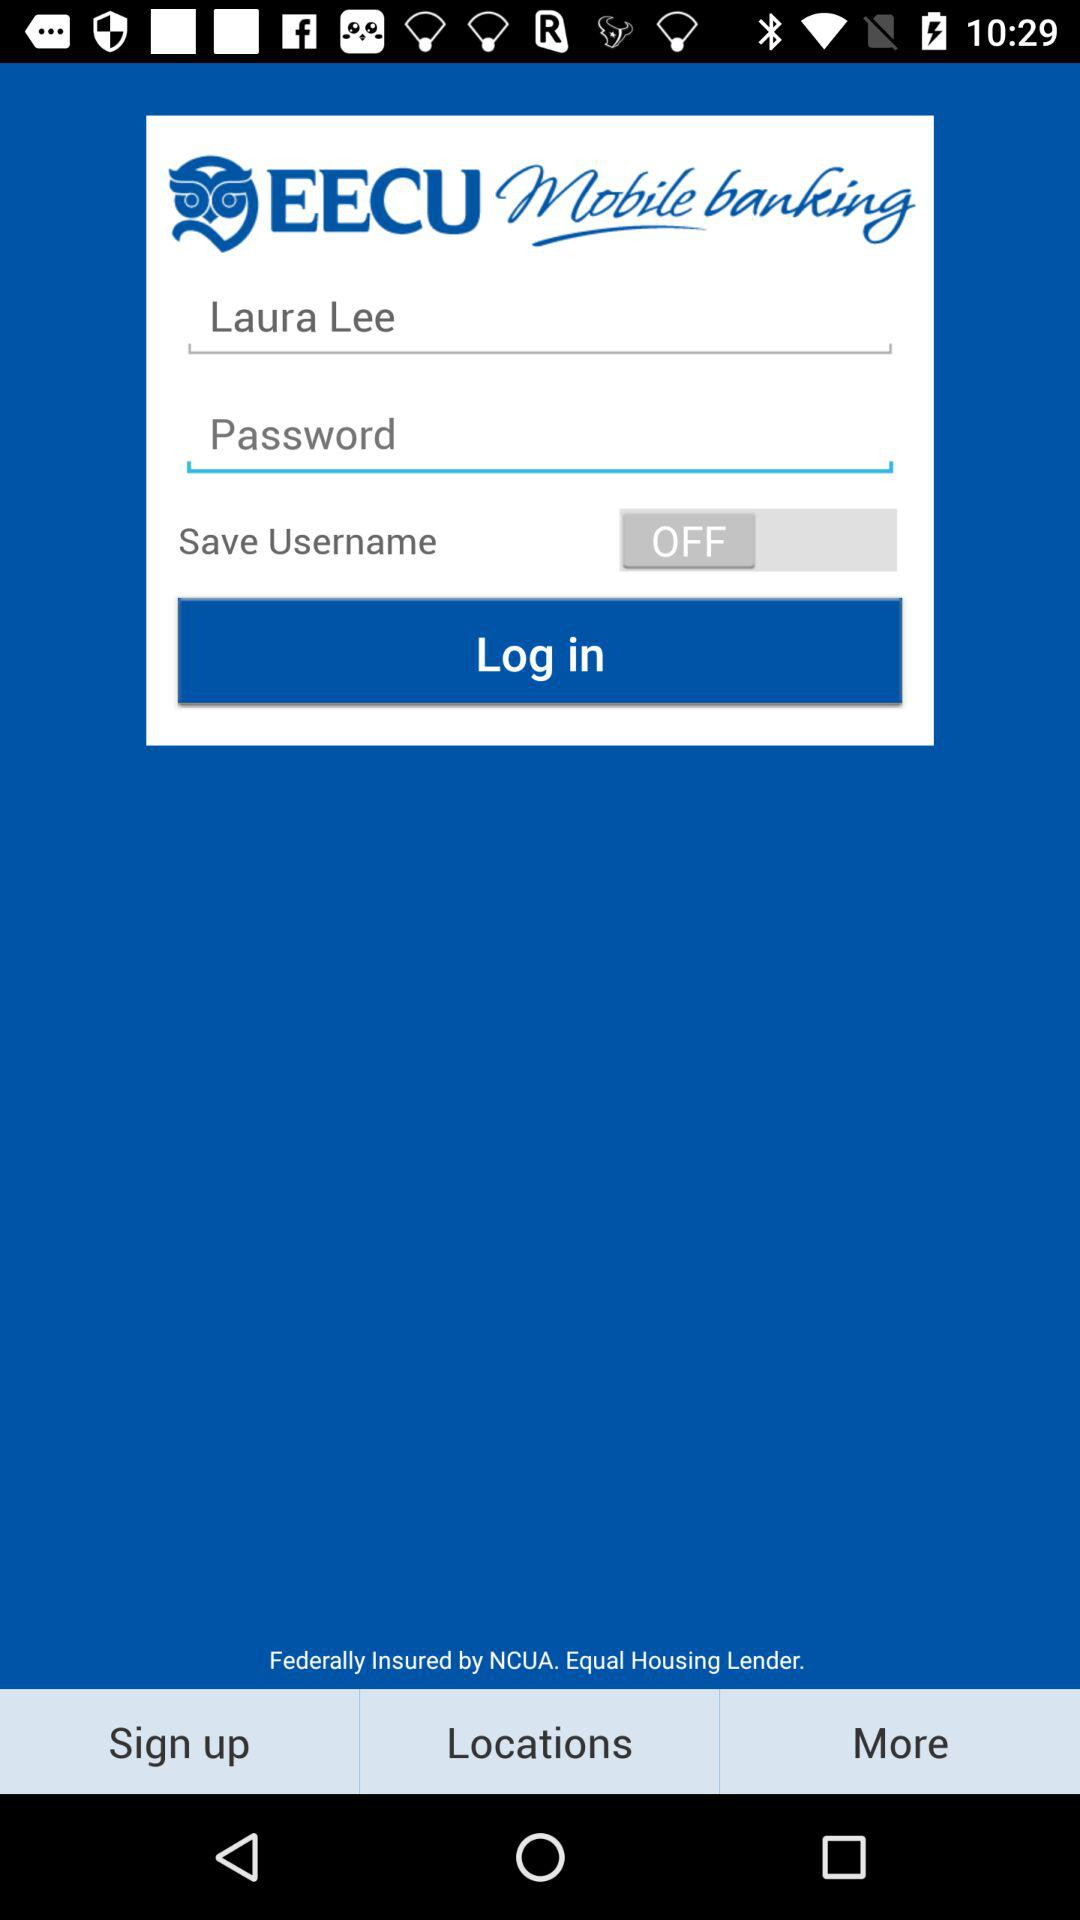What is the application name? The application name is "EECU". 